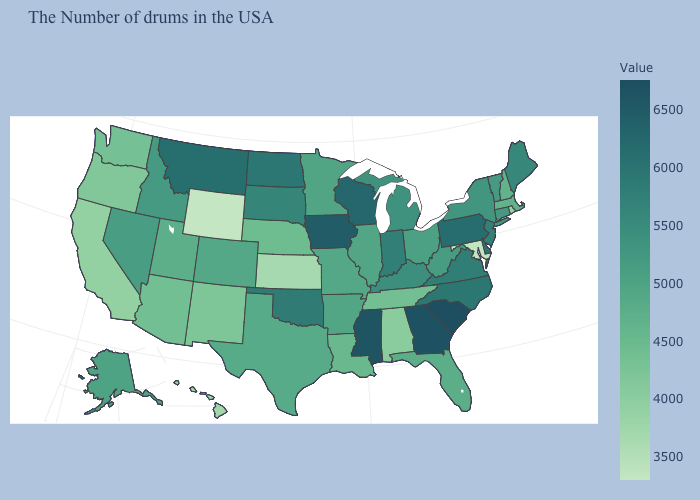Which states have the lowest value in the MidWest?
Keep it brief. Kansas. Does Texas have a lower value than Washington?
Write a very short answer. No. Which states have the highest value in the USA?
Write a very short answer. South Carolina. Does the map have missing data?
Keep it brief. No. Which states have the highest value in the USA?
Concise answer only. South Carolina. Which states have the lowest value in the West?
Answer briefly. Wyoming. Among the states that border Texas , does New Mexico have the lowest value?
Answer briefly. Yes. 